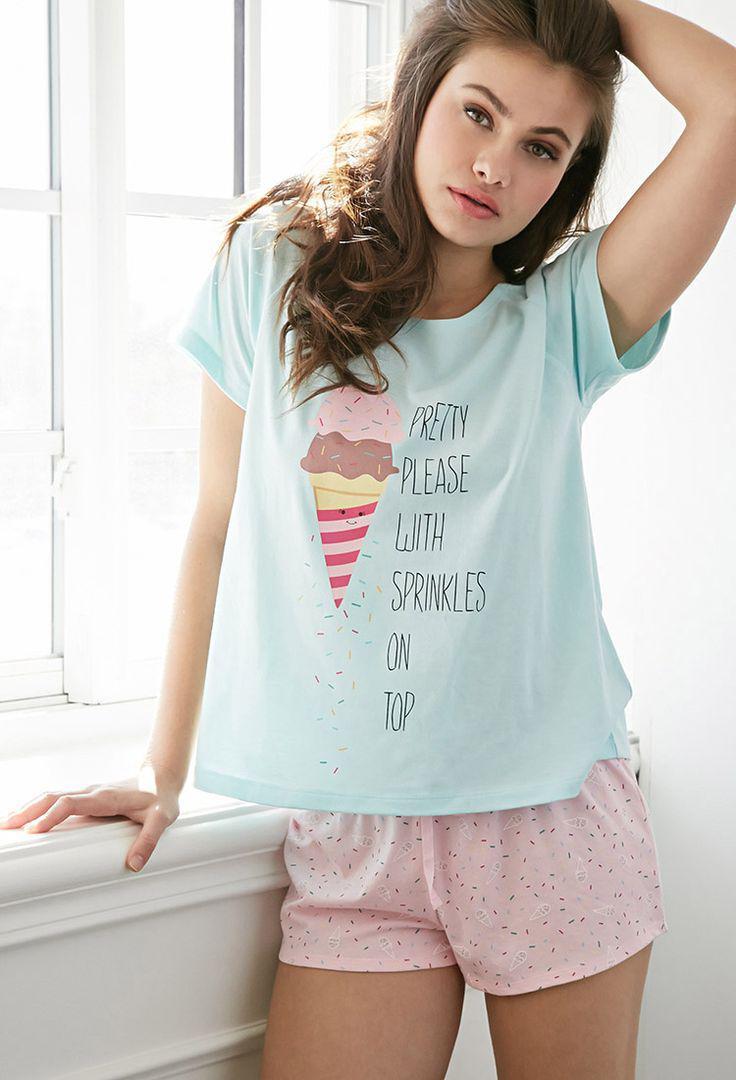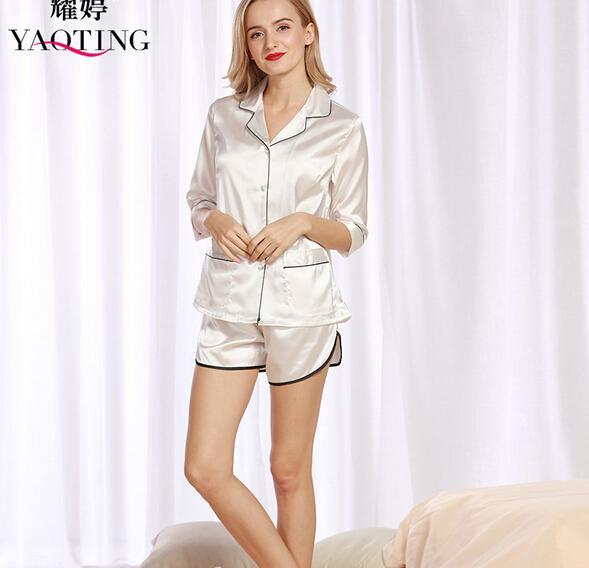The first image is the image on the left, the second image is the image on the right. Analyze the images presented: Is the assertion "One model is blonde and wears something made of satiny, shiny material, while the other model wears shorts with a short-sleeved top that doesn't bare her midriff." valid? Answer yes or no. Yes. The first image is the image on the left, the second image is the image on the right. Considering the images on both sides, is "A pajama set is a pair of short pants paired with a t-shirt top with short sleeves and design printed on the front." valid? Answer yes or no. Yes. 